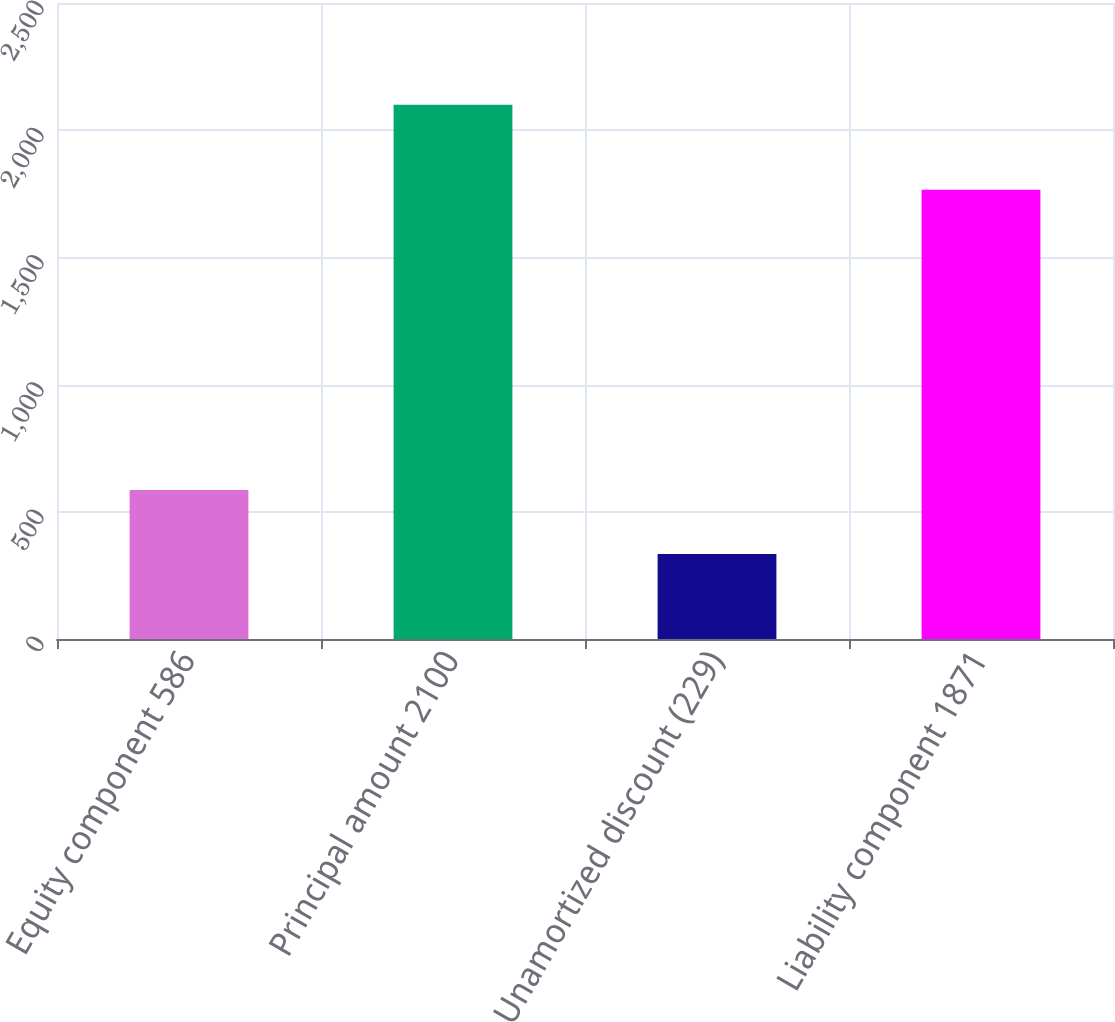<chart> <loc_0><loc_0><loc_500><loc_500><bar_chart><fcel>Equity component 586<fcel>Principal amount 2100<fcel>Unamortized discount (229)<fcel>Liability component 1871<nl><fcel>586<fcel>2100<fcel>334<fcel>1766<nl></chart> 